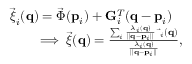<formula> <loc_0><loc_0><loc_500><loc_500>\begin{array} { r l } & { \vec { \xi } _ { i } ( { q } ) = \vec { \Phi } ( { p } _ { i } ) + { G } _ { i } ^ { T } ( { q } - { p } _ { i } ) } \\ & { \quad \implies \vec { \xi } ( { q } ) = \frac { \sum _ { i } \frac { \lambda _ { i } ( { q } ) } { | | { q } - { p } _ { i } | | } \, \vec { \xi } _ { i } ( { q } ) } { \frac { \lambda _ { i } ( { q } ) } { | | { q } - { p } _ { i } | | } } , } \end{array}</formula> 